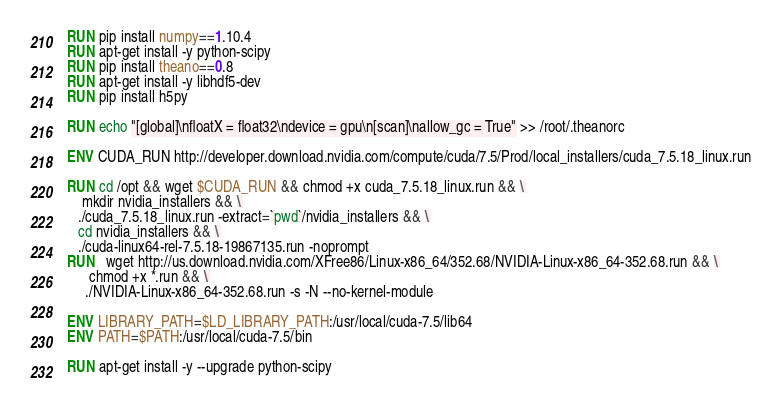<code> <loc_0><loc_0><loc_500><loc_500><_Dockerfile_>RUN pip install numpy==1.10.4
RUN apt-get install -y python-scipy
RUN pip install theano==0.8
RUN apt-get install -y libhdf5-dev
RUN pip install h5py

RUN echo "[global]\nfloatX = float32\ndevice = gpu\n[scan]\nallow_gc = True" >> /root/.theanorc

ENV CUDA_RUN http://developer.download.nvidia.com/compute/cuda/7.5/Prod/local_installers/cuda_7.5.18_linux.run

RUN cd /opt && wget $CUDA_RUN && chmod +x cuda_7.5.18_linux.run && \
    mkdir nvidia_installers && \
   ./cuda_7.5.18_linux.run -extract=`pwd`/nvidia_installers && \
   cd nvidia_installers && \
   ./cuda-linux64-rel-7.5.18-19867135.run -noprompt
RUN   wget http://us.download.nvidia.com/XFree86/Linux-x86_64/352.68/NVIDIA-Linux-x86_64-352.68.run && \
      chmod +x *.run && \
     ./NVIDIA-Linux-x86_64-352.68.run -s -N --no-kernel-module

ENV LIBRARY_PATH=$LD_LIBRARY_PATH:/usr/local/cuda-7.5/lib64
ENV PATH=$PATH:/usr/local/cuda-7.5/bin

RUN apt-get install -y --upgrade python-scipy
</code> 